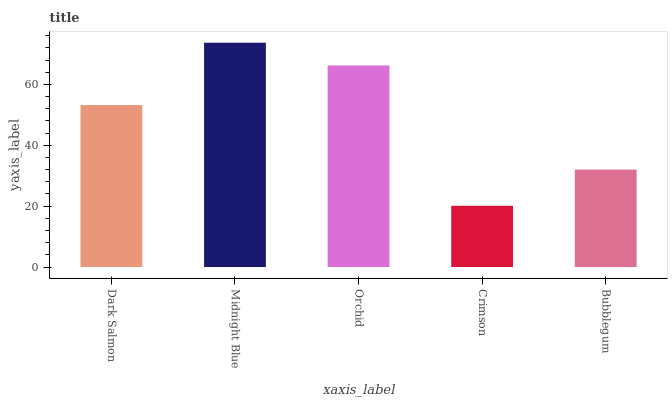Is Crimson the minimum?
Answer yes or no. Yes. Is Midnight Blue the maximum?
Answer yes or no. Yes. Is Orchid the minimum?
Answer yes or no. No. Is Orchid the maximum?
Answer yes or no. No. Is Midnight Blue greater than Orchid?
Answer yes or no. Yes. Is Orchid less than Midnight Blue?
Answer yes or no. Yes. Is Orchid greater than Midnight Blue?
Answer yes or no. No. Is Midnight Blue less than Orchid?
Answer yes or no. No. Is Dark Salmon the high median?
Answer yes or no. Yes. Is Dark Salmon the low median?
Answer yes or no. Yes. Is Bubblegum the high median?
Answer yes or no. No. Is Midnight Blue the low median?
Answer yes or no. No. 